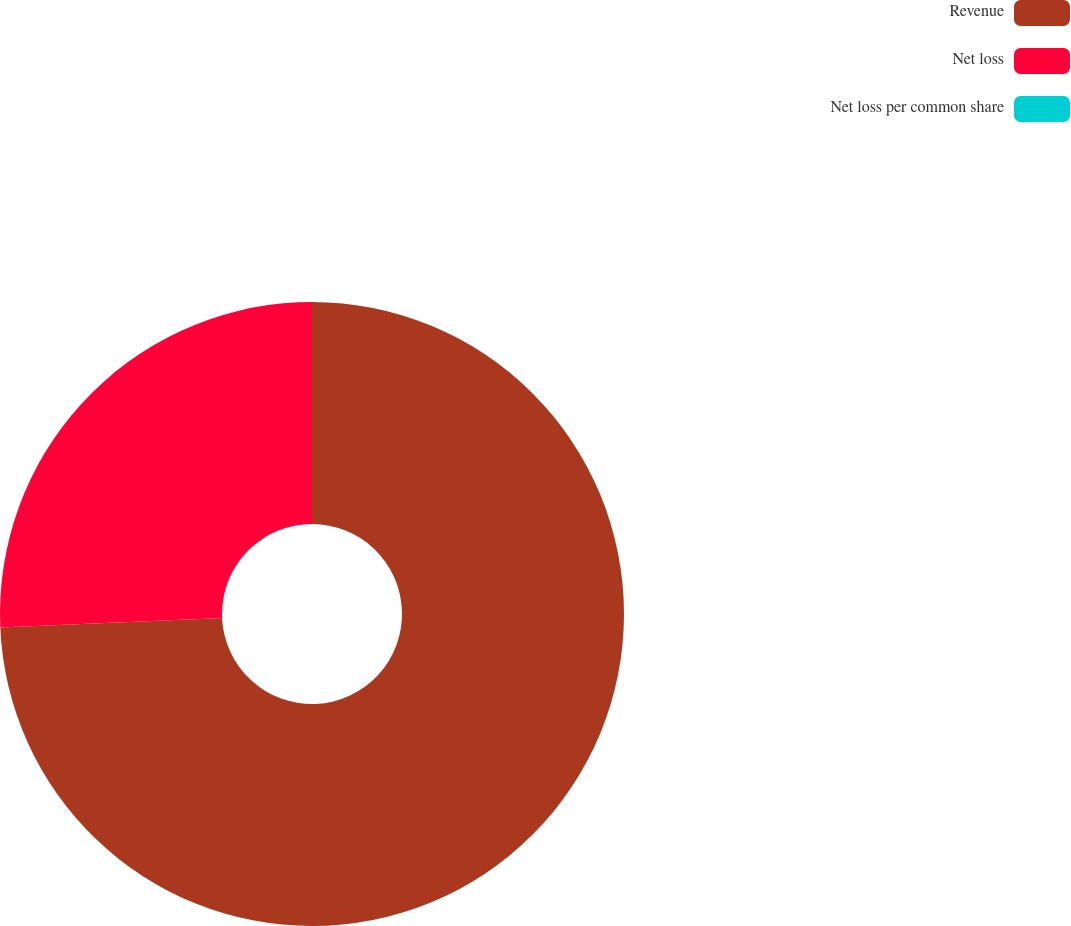Convert chart to OTSL. <chart><loc_0><loc_0><loc_500><loc_500><pie_chart><fcel>Revenue<fcel>Net loss<fcel>Net loss per common share<nl><fcel>74.31%<fcel>25.69%<fcel>0.0%<nl></chart> 